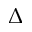<formula> <loc_0><loc_0><loc_500><loc_500>\Delta</formula> 